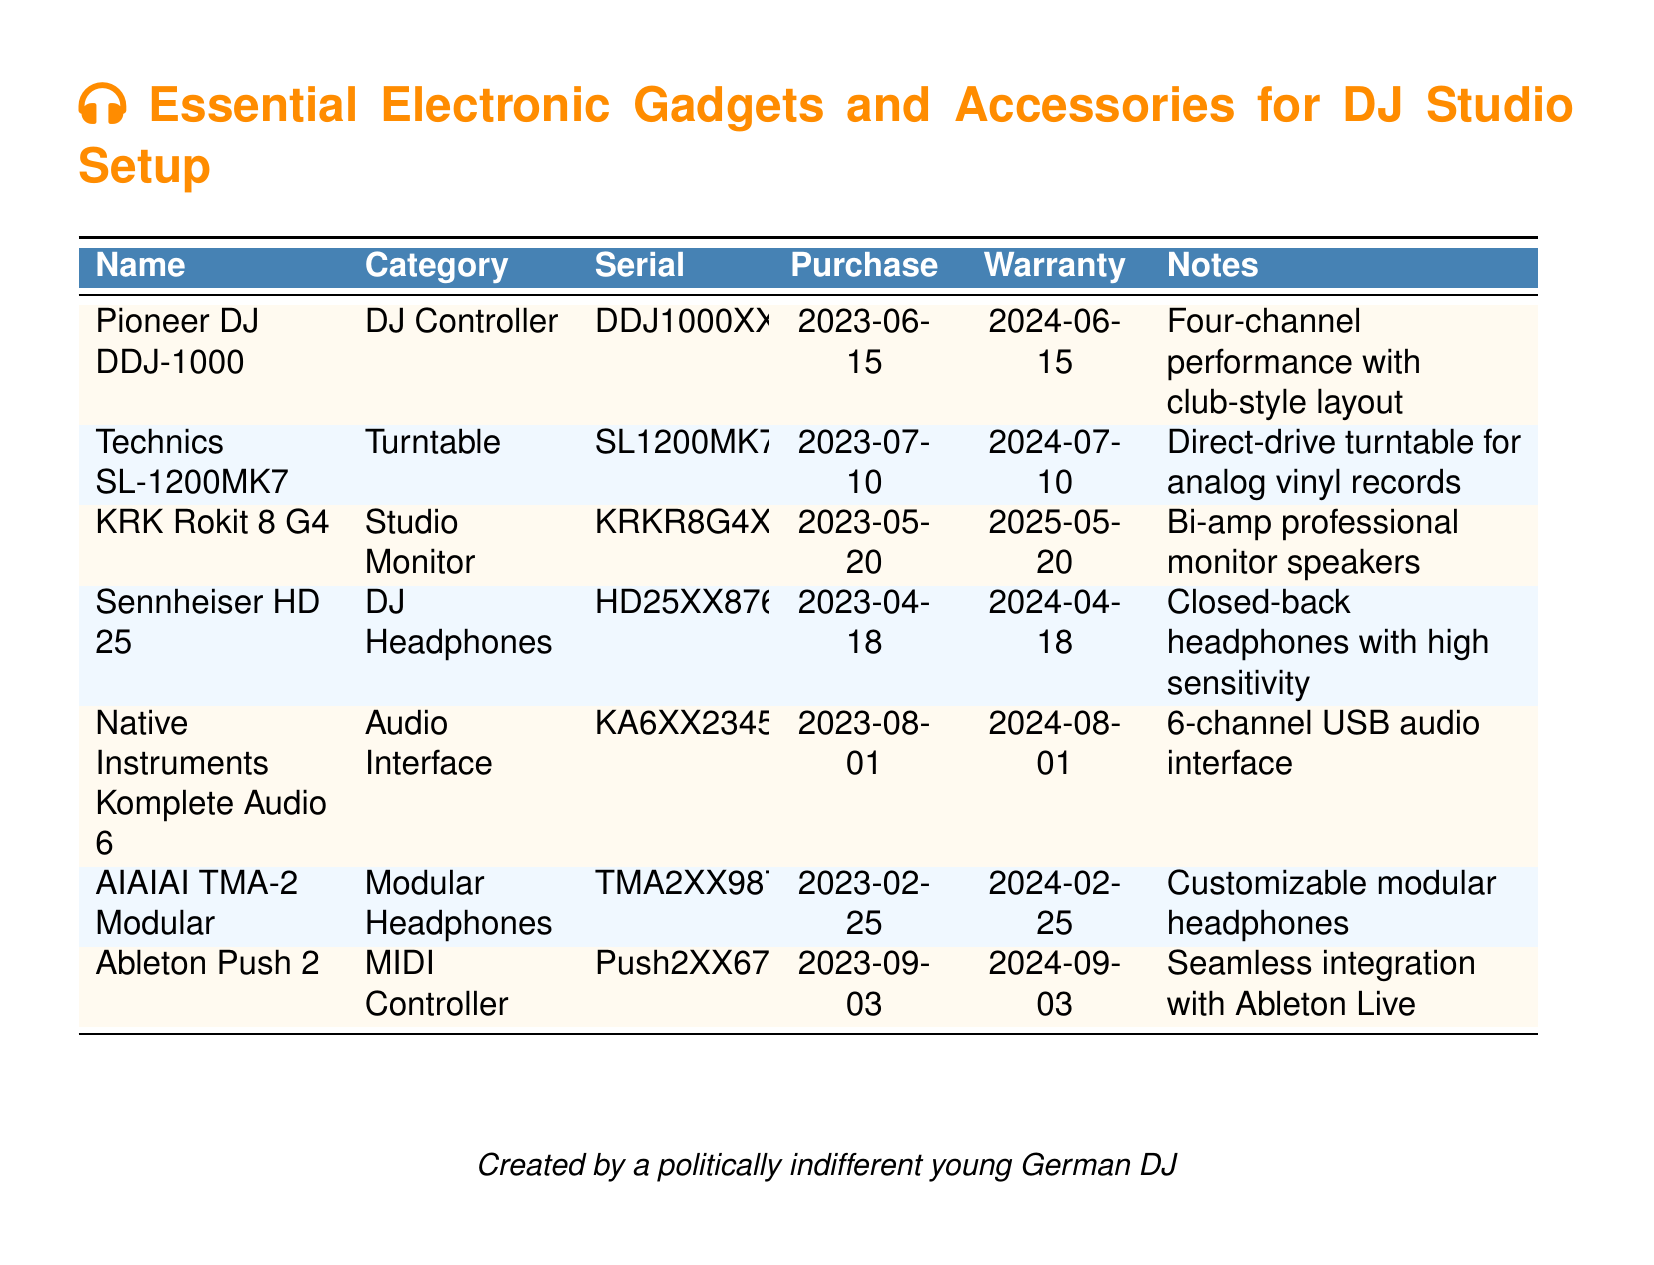What is the purchase date of the Pioneer DJ DDJ-1000? The purchase date of the Pioneer DJ DDJ-1000 is specified in the document under the "Purchase" column.
Answer: 2023-06-15 How long is the warranty for the Sennheiser HD 25? The warranty period for the Sennheiser HD 25 is noted in the document, which typically lasts for a year from the purchase date.
Answer: 2024-04-18 What type of product is the KRK Rokit 8 G4? The document categorizes the KRK Rokit 8 G4 in the "Category" column.
Answer: Studio Monitor How many channels does the Native Instruments Komplete Audio 6 have? The number of channels for the Native Instruments Komplete Audio 6 is outlined in the "Notes" section of the document.
Answer: 6-channel Which item was purchased last? The latest purchase date can be derived by comparing the purchase dates of all items in the list.
Answer: Ableton Push 2 What is the warranty period for the Technics SL-1200MK7? The warranty period can be found next to the Technics SL-1200MK7 under the "Warranty" column.
Answer: 2024-07-10 What type of headphones are the AIAIAI TMA-2 Modular? The document specifies the type of headphones in the "Category" column.
Answer: Modular Headphones What model number does the DJ Controller have? The serial number of the DJ Controller is listed in the corresponding column in the document.
Answer: DDJ1000XX1234 